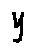<formula> <loc_0><loc_0><loc_500><loc_500>y</formula> 